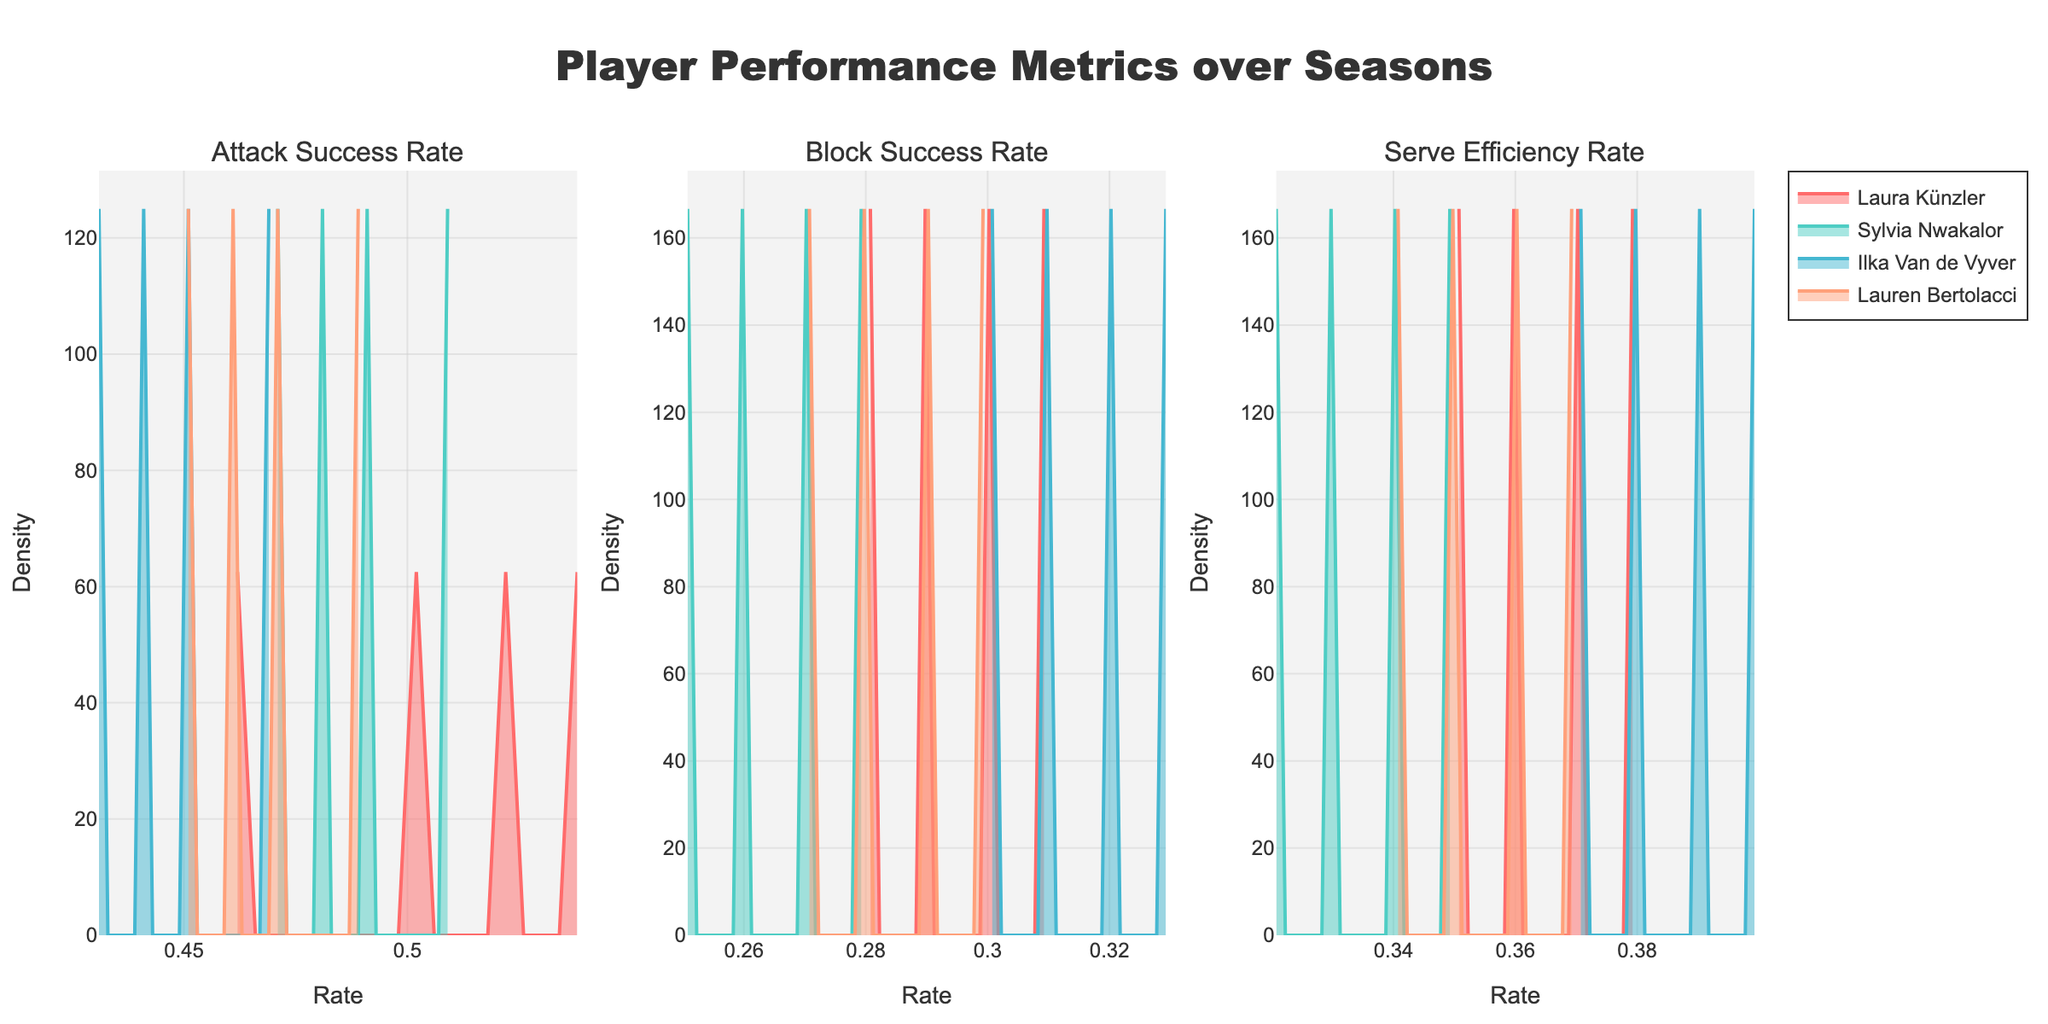What is the title of the figure? The title is displayed at the top of the figure, reflecting its overall theme or main point.
Answer: Player Performance Metrics over Seasons Which metrics are represented in the subplots? The subplot titles indicate the three different metrics measured: "Attack Success Rate," "Block Success Rate," and "Serve Efficiency Rate."
Answer: Attack Success Rate, Block Success Rate, Serve Efficiency Rate Which player has the highest peak density in the Attack Success Rate subplot? By examining the highest density peak in the Attack Success Rate subplot and comparing the players' curves, we can identify the player with the highest density.
Answer: Laura Künzler How do the serve efficiency rates compare between Ilka Van de Vyver and Lauren Bertolacci? By comparing the density curves for both players in the Serve Efficiency Rate subplot, we can analyze their performance. Ilka Van de Vyver has a higher peak density, indicating more consistent serve efficiency rates around the peak.
Answer: Ilka Van de Vyver has a higher peak density What is the general trend in Block Success Rates from 2018 to 2021? By examining the positions and densities of the density plots for each year, we can observe if there is an upward or downward shift over the years.
Answer: Generally increasing Who has the most consistent performance in Serve Efficiency Rate? The consistency can be judged by the spread and peak of the density curve. Narrower, taller curves indicate more consistent performance.
Answer: Ilka Van de Vyver Which player shows a noticeable improvement in Attack Success Rate over the seasons? We need to compare the density plots of players across the seasons. The player with a significant shift to higher attack success rates over time shows improvement.
Answer: Laura Künzler Is there a player who has consistently high Block Success Rates? By analyzing the Block Success Rate subplot and finding the player with consistently high-density peaks across the seasons, we can identify such a player.
Answer: Ilka Van de Vyver How does Sylvia Nwakalor's Serve Efficiency Rate change from 2018 to 2021? By observing the changes in Sylvia Nwakalor's Serve Efficiency Rate density curves for the given seasons, we can see if her performance improves, declines, or remains stable.
Answer: Slightly increases 